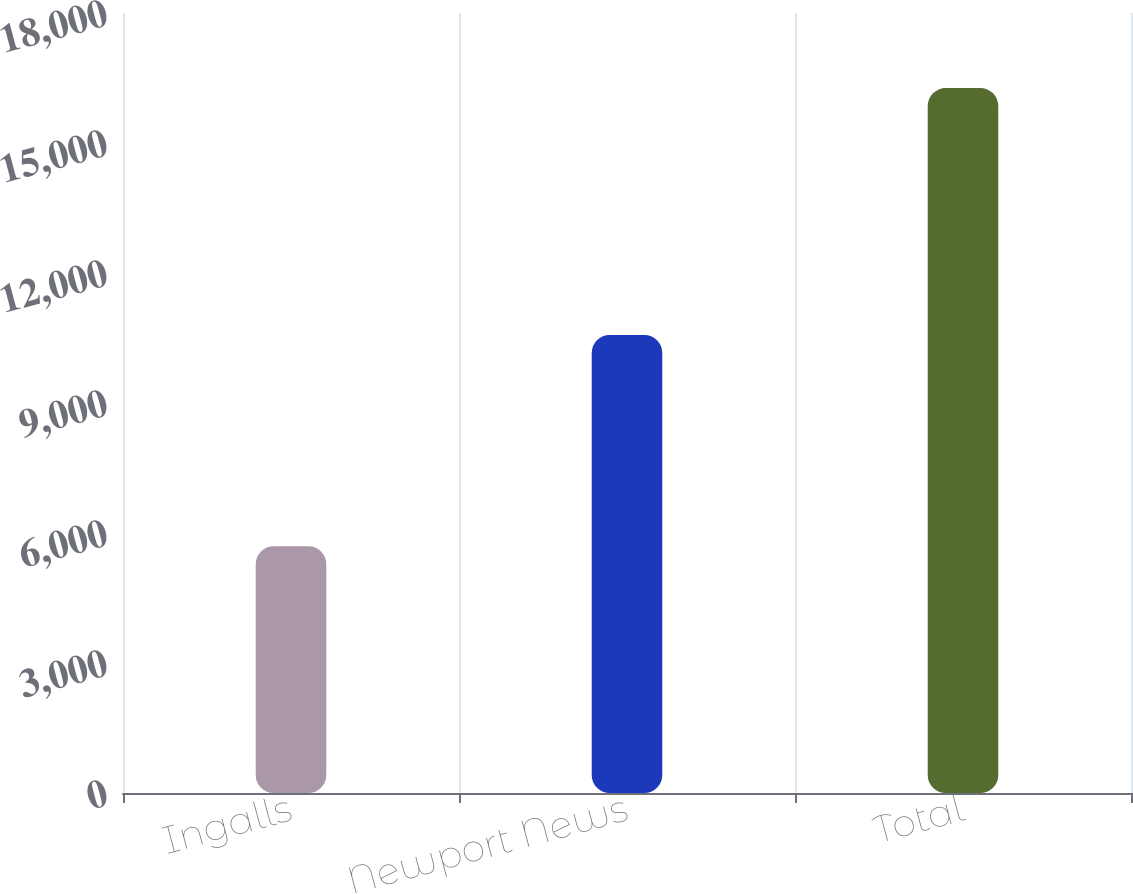Convert chart. <chart><loc_0><loc_0><loc_500><loc_500><bar_chart><fcel>Ingalls<fcel>Newport News<fcel>Total<nl><fcel>5696<fcel>10572<fcel>16268<nl></chart> 